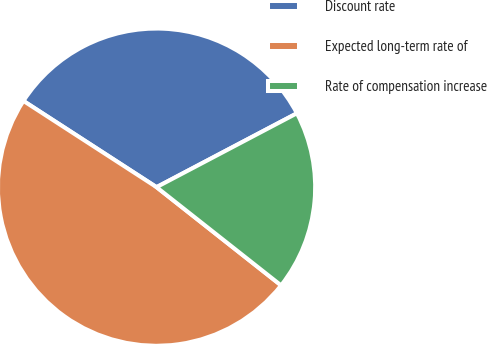Convert chart. <chart><loc_0><loc_0><loc_500><loc_500><pie_chart><fcel>Discount rate<fcel>Expected long-term rate of<fcel>Rate of compensation increase<nl><fcel>33.14%<fcel>48.52%<fcel>18.34%<nl></chart> 